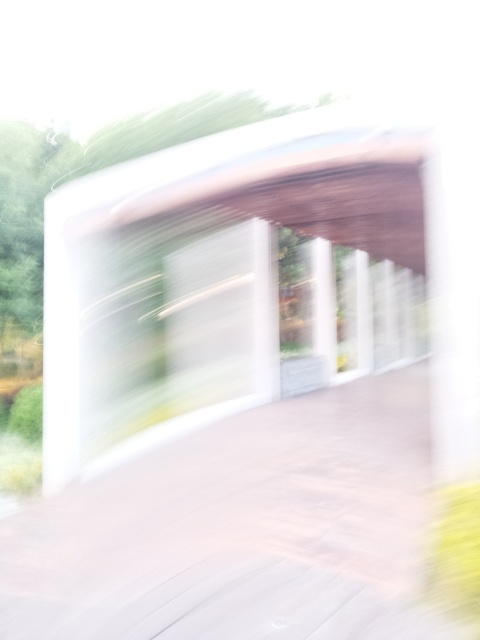What are some techniques to deliberately create a blur effect in a photo like this? To deliberately create a blur effect, photographers often use techniques like panning, where the camera follows a moving subject at a slow shutter speed; motion blur, capturing the movement of subjects while keeping the camera still; or zooming while the shutter is open. Another method is to manually defocus the camera to blur the scene intentionally. Each technique can yield a unique type of blur that adds dynamicism or emotional depth to an image. 